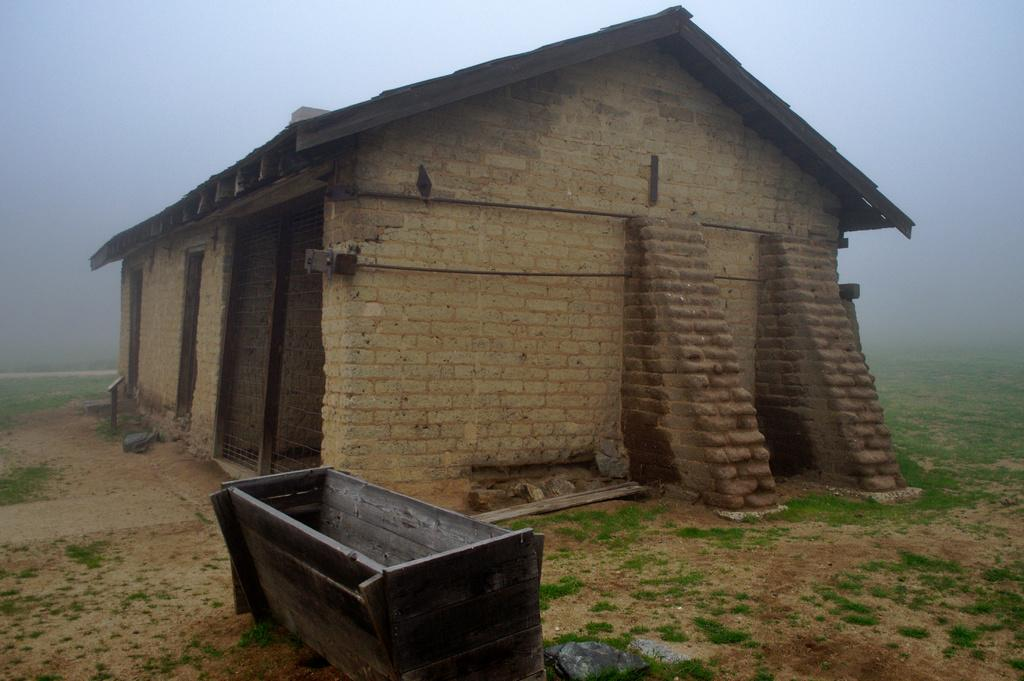What type of structure is present in the image? There is a hut in the image. What material is used for the walls of the hut? The hut has brick walls. What material is used for the rooftop of the hut? The hut has a wooden rooftop. What is the surrounding environment like in the image? The hut is surrounded by fog and grass. What other object can be seen in the image? There is a wooden tub in the image. Can you tell me which organization is responsible for maintaining the eye in the image? There is no eye present in the image, so it is not possible to determine which organization might be responsible for maintaining it. 